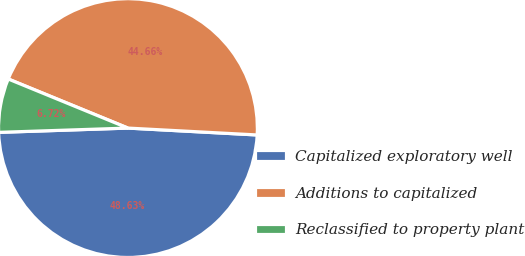Convert chart. <chart><loc_0><loc_0><loc_500><loc_500><pie_chart><fcel>Capitalized exploratory well<fcel>Additions to capitalized<fcel>Reclassified to property plant<nl><fcel>48.63%<fcel>44.66%<fcel>6.72%<nl></chart> 